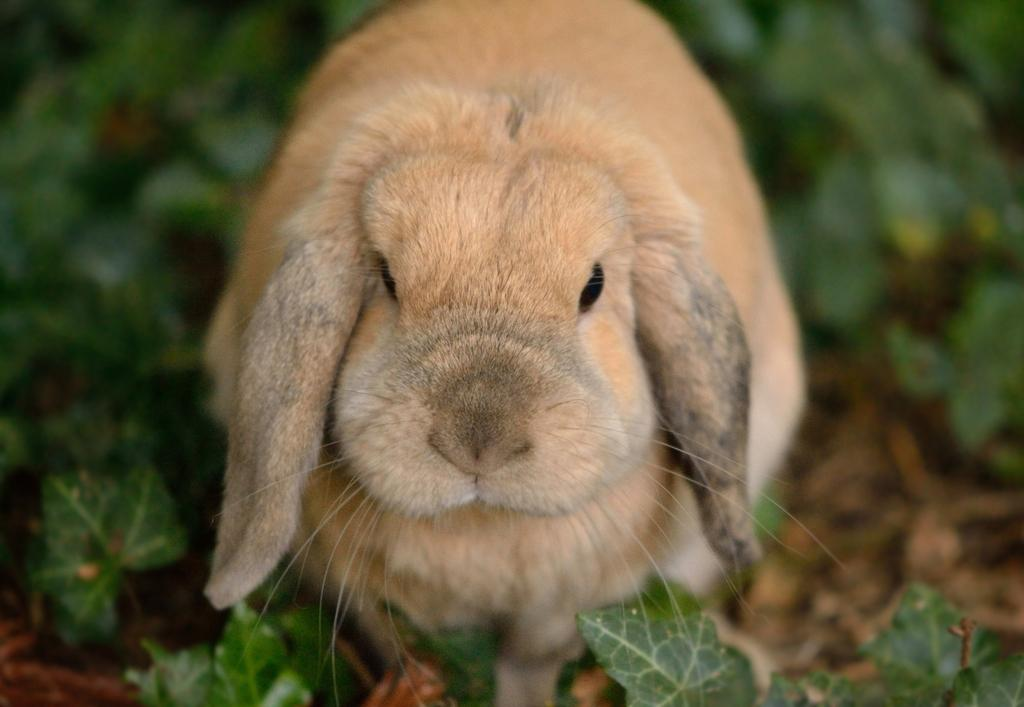What animal is present in the image? There is a rabbit in the image. Where is the rabbit located? The rabbit is on the land. What type of vegetation can be seen in the image? There are plants in the image. What part of the plants is visible? The plants have leaves. What caption is written on the rabbit's ear in the image? There is no caption written on the rabbit's ear in the image. Can you tell me what the rabbit is saying to the plants in the image? The rabbit is not talking in the image, as it is a still image and does not depict any conversation or interaction between the rabbit and the plants. 